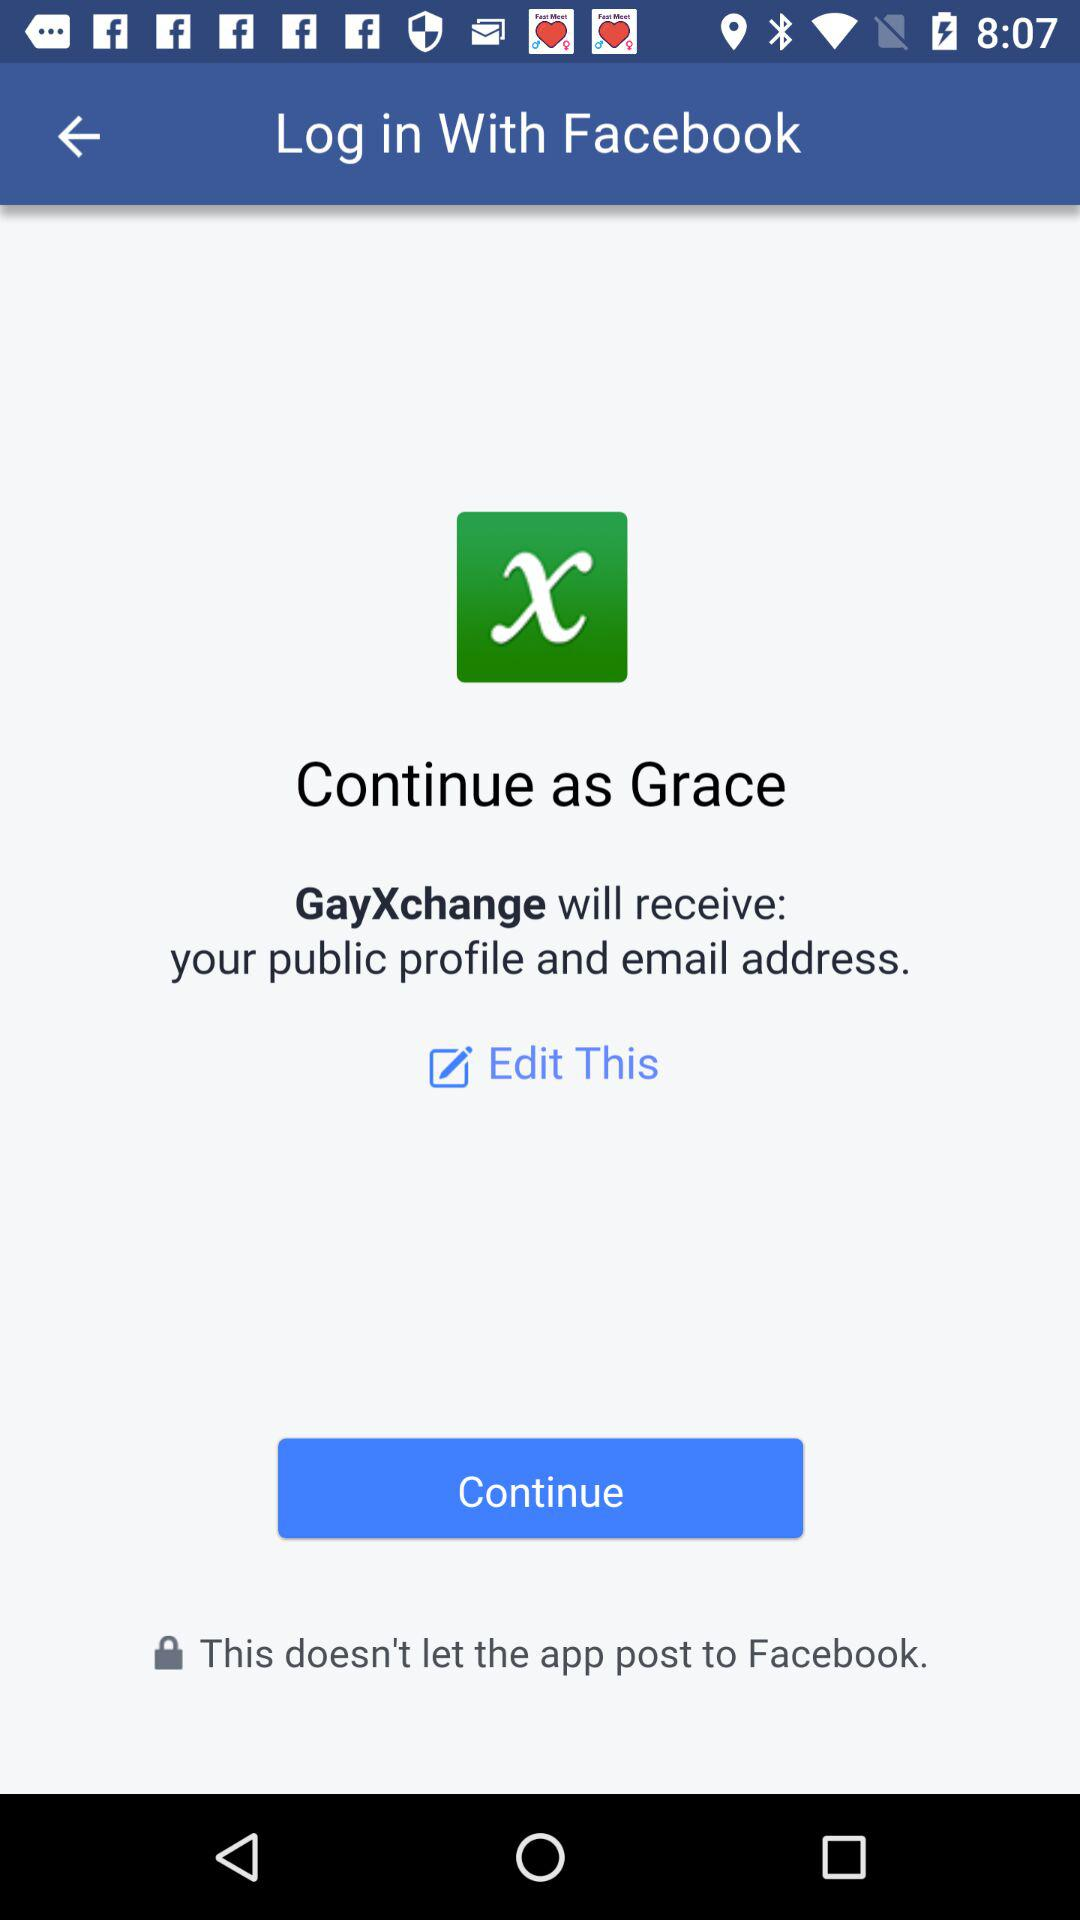What is the user name? The user name is Grace. 